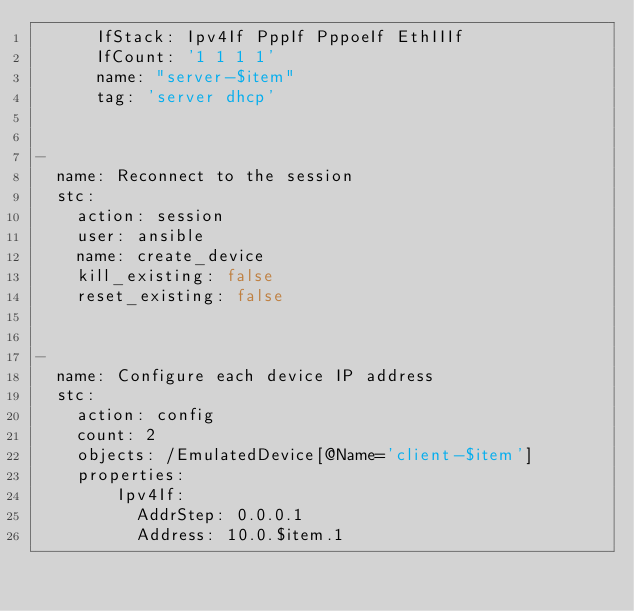Convert code to text. <code><loc_0><loc_0><loc_500><loc_500><_YAML_>      IfStack: Ipv4If PppIf PppoeIf EthIIIf
      IfCount: '1 1 1 1'
      name: "server-$item"
      tag: 'server dhcp'


- 
  name: Reconnect to the session
  stc: 
    action: session
    user: ansible
    name: create_device
    kill_existing: false
    reset_existing: false


-
  name: Configure each device IP address
  stc: 
    action: config
    count: 2
    objects: /EmulatedDevice[@Name='client-$item']
    properties:
        Ipv4If: 
          AddrStep: 0.0.0.1
          Address: 10.0.$item.1

</code> 